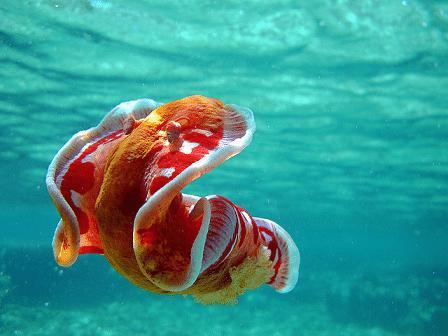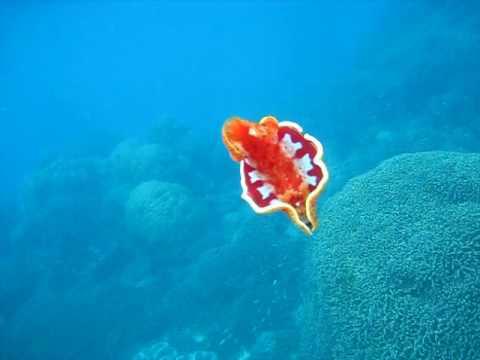The first image is the image on the left, the second image is the image on the right. Given the left and right images, does the statement "At least one image shows a jellyfish with a folded appearance and no tendrils trailing from it." hold true? Answer yes or no. Yes. The first image is the image on the left, the second image is the image on the right. Given the left and right images, does the statement "The sea creature in the image on the right looks like a cross between a clownfish and a jellyfish, with its bright orange body and white blotches." hold true? Answer yes or no. Yes. 